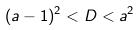<formula> <loc_0><loc_0><loc_500><loc_500>( a - 1 ) ^ { 2 } < D < a ^ { 2 }</formula> 